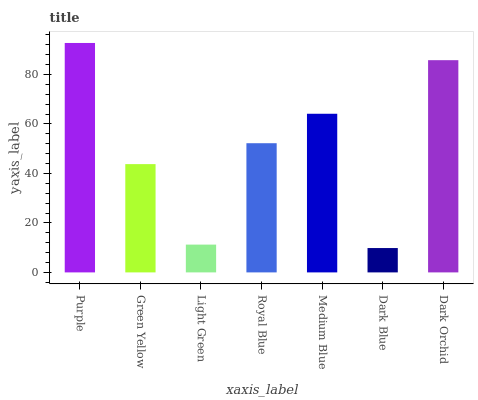Is Dark Blue the minimum?
Answer yes or no. Yes. Is Purple the maximum?
Answer yes or no. Yes. Is Green Yellow the minimum?
Answer yes or no. No. Is Green Yellow the maximum?
Answer yes or no. No. Is Purple greater than Green Yellow?
Answer yes or no. Yes. Is Green Yellow less than Purple?
Answer yes or no. Yes. Is Green Yellow greater than Purple?
Answer yes or no. No. Is Purple less than Green Yellow?
Answer yes or no. No. Is Royal Blue the high median?
Answer yes or no. Yes. Is Royal Blue the low median?
Answer yes or no. Yes. Is Light Green the high median?
Answer yes or no. No. Is Medium Blue the low median?
Answer yes or no. No. 